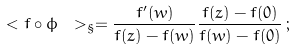Convert formula to latex. <formula><loc_0><loc_0><loc_500><loc_500>\ < f \circ \phi \ > _ { \S } = \frac { f ^ { \prime } ( w ) } { f ( z ) - f ( w ) } \frac { f ( z ) - f ( 0 ) } { f ( w ) - f ( 0 ) } \, ;</formula> 